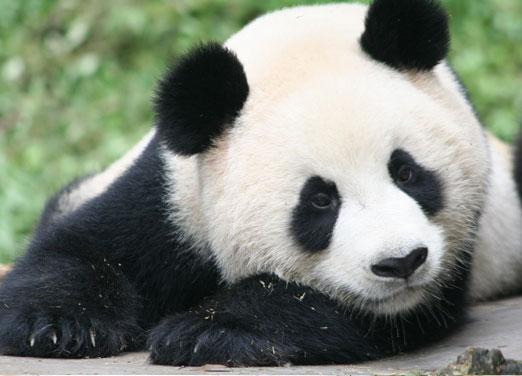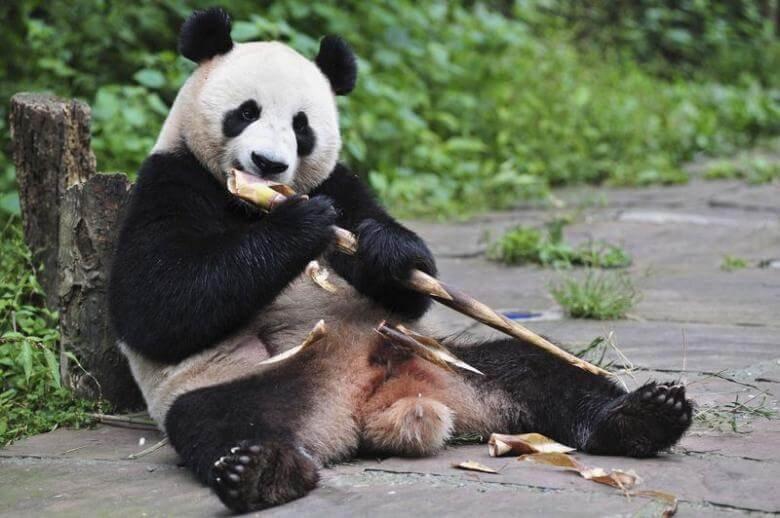The first image is the image on the left, the second image is the image on the right. For the images displayed, is the sentence "There is a single panda sitting in the grass in the image on the left." factually correct? Answer yes or no. No. The first image is the image on the left, the second image is the image on the right. Given the left and right images, does the statement "One image shows a panda at play." hold true? Answer yes or no. No. The first image is the image on the left, the second image is the image on the right. For the images shown, is this caption "A panda has both front paws wrapped around something that is more round than stick-shaped." true? Answer yes or no. No. 